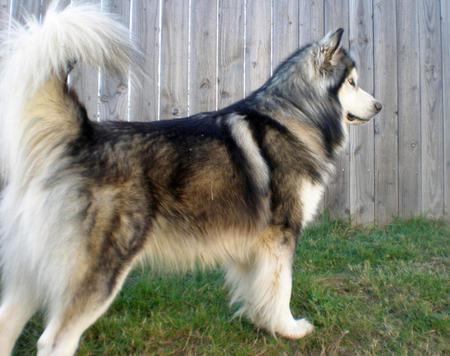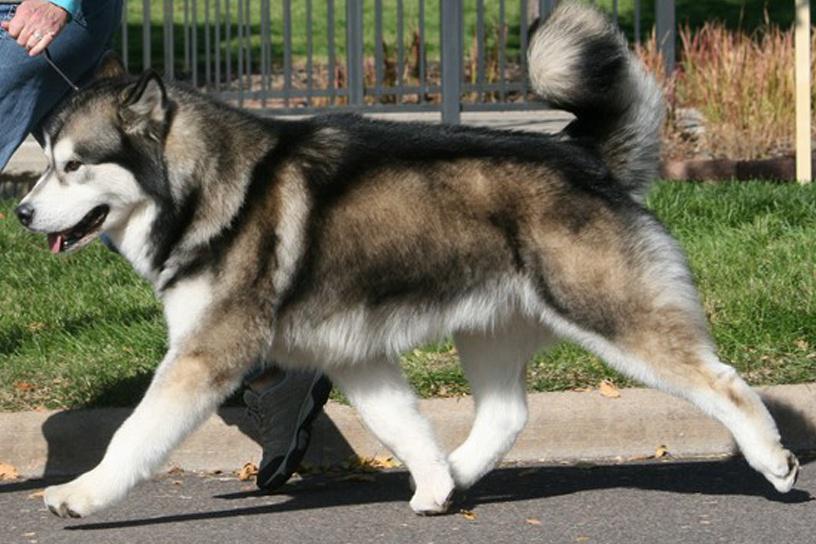The first image is the image on the left, the second image is the image on the right. Considering the images on both sides, is "There is at least one person visible behind a dog." valid? Answer yes or no. Yes. 